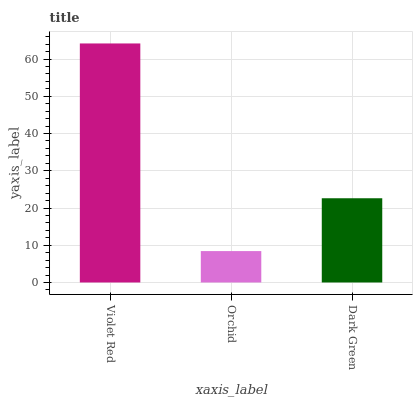Is Orchid the minimum?
Answer yes or no. Yes. Is Violet Red the maximum?
Answer yes or no. Yes. Is Dark Green the minimum?
Answer yes or no. No. Is Dark Green the maximum?
Answer yes or no. No. Is Dark Green greater than Orchid?
Answer yes or no. Yes. Is Orchid less than Dark Green?
Answer yes or no. Yes. Is Orchid greater than Dark Green?
Answer yes or no. No. Is Dark Green less than Orchid?
Answer yes or no. No. Is Dark Green the high median?
Answer yes or no. Yes. Is Dark Green the low median?
Answer yes or no. Yes. Is Orchid the high median?
Answer yes or no. No. Is Orchid the low median?
Answer yes or no. No. 